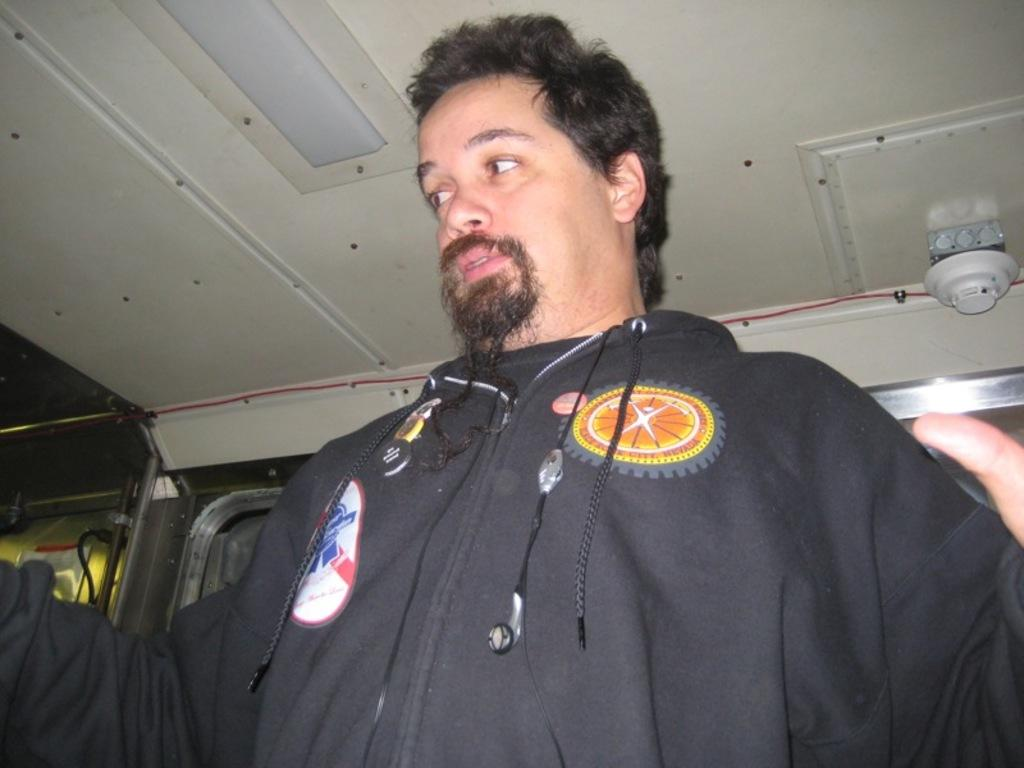Who or what is present in the image? There is a person in the image. What is the person doing in the image? The person is looking at the opposite side. What is the person wearing in the image? The person is wearing a black dress. How many balloons does the person have in the image? There are no balloons present in the image. What is the person's level of expertise in the image? The provided facts do not mention the person's level of expertise or any specific activity they might be engaged in. 